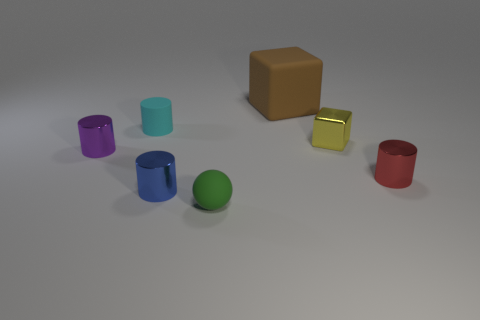Subtract all rubber cylinders. How many cylinders are left? 3 Subtract 2 cylinders. How many cylinders are left? 2 Subtract all blue cylinders. How many cylinders are left? 3 Add 2 big red shiny cylinders. How many objects exist? 9 Subtract all spheres. How many objects are left? 6 Subtract all purple cylinders. Subtract all yellow blocks. How many cylinders are left? 3 Subtract all small cyan rubber objects. Subtract all yellow objects. How many objects are left? 5 Add 1 purple shiny cylinders. How many purple shiny cylinders are left? 2 Add 6 blue cylinders. How many blue cylinders exist? 7 Subtract 0 cyan spheres. How many objects are left? 7 